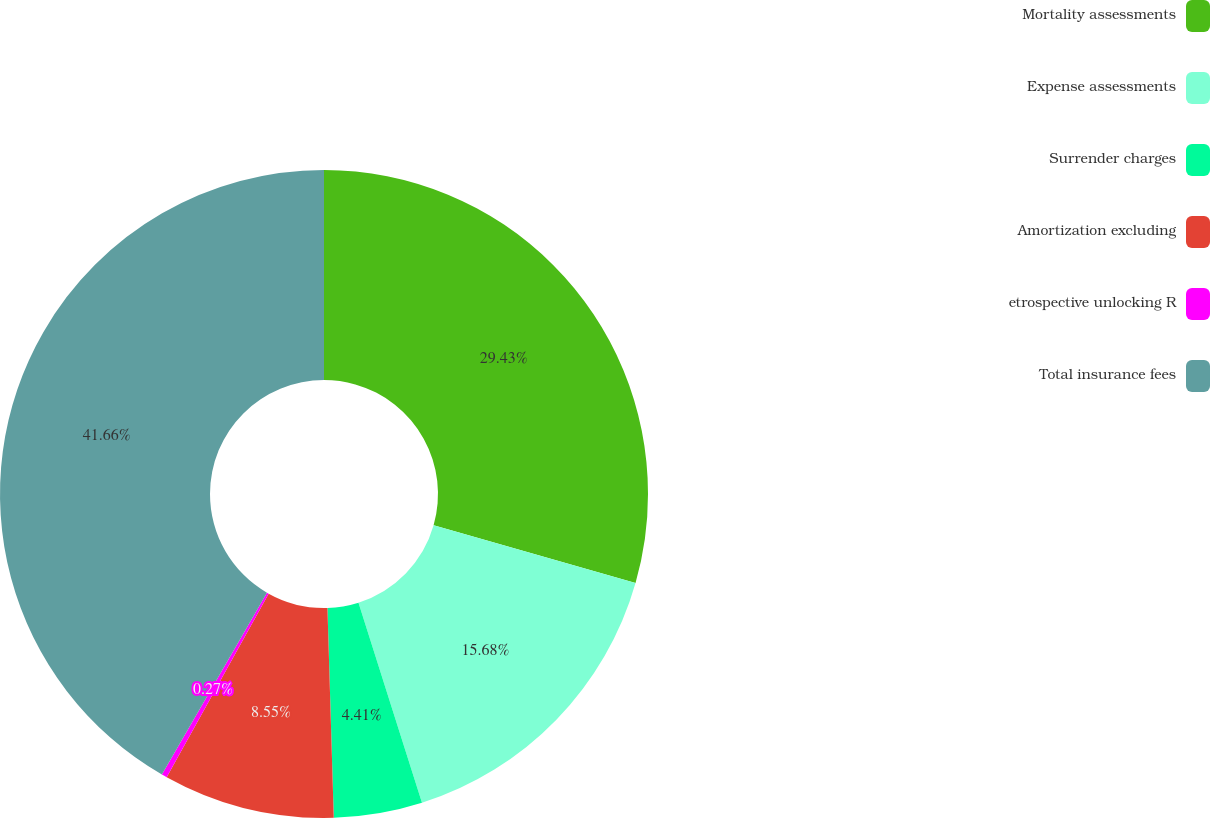Convert chart to OTSL. <chart><loc_0><loc_0><loc_500><loc_500><pie_chart><fcel>Mortality assessments<fcel>Expense assessments<fcel>Surrender charges<fcel>Amortization excluding<fcel>etrospective unlocking R<fcel>Total insurance fees<nl><fcel>29.43%<fcel>15.68%<fcel>4.41%<fcel>8.55%<fcel>0.27%<fcel>41.66%<nl></chart> 